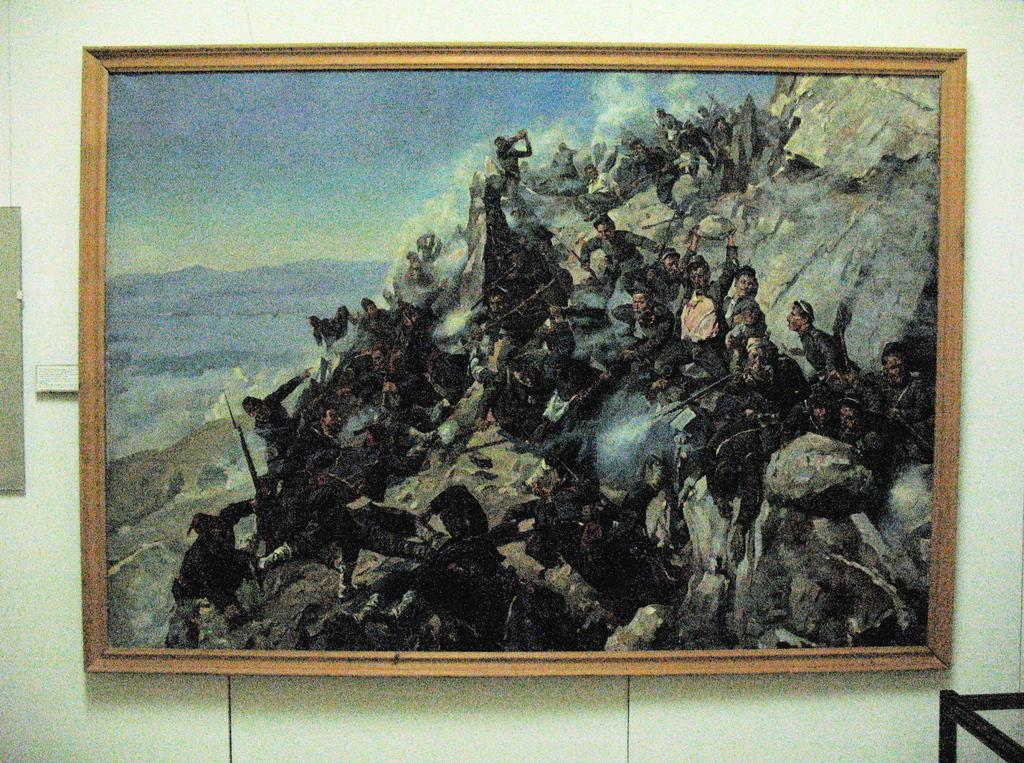What is on the wall in the image? There is a frame on the wall in the image. What is depicted within the frame? The frame contains a group of people and some objects. What can be seen in the background of the scene within the frame? The sky is visible in the frame. What type of stove is visible in the image? There is no stove present in the image. What kind of insurance policy is being discussed in the image? There is no discussion of insurance in the image. 